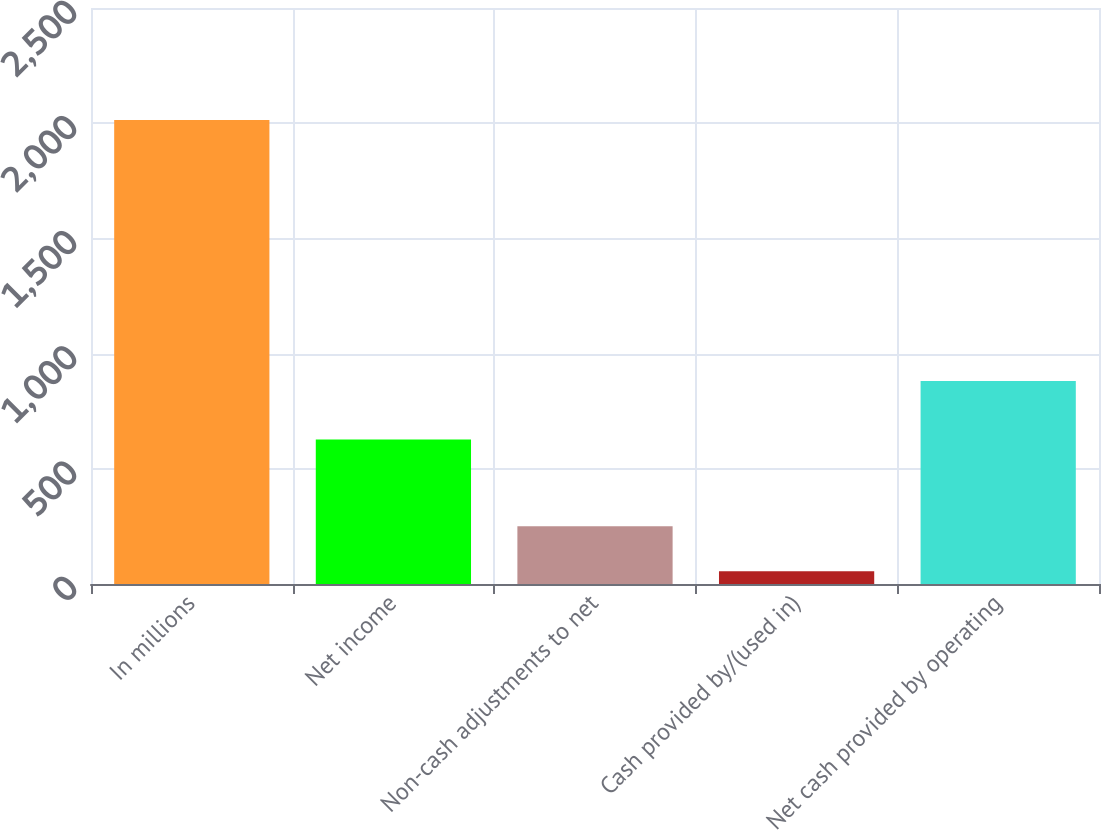Convert chart. <chart><loc_0><loc_0><loc_500><loc_500><bar_chart><fcel>In millions<fcel>Net income<fcel>Non-cash adjustments to net<fcel>Cash provided by/(used in)<fcel>Net cash provided by operating<nl><fcel>2014<fcel>627.5<fcel>250.72<fcel>54.8<fcel>880.9<nl></chart> 